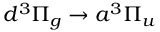<formula> <loc_0><loc_0><loc_500><loc_500>d ^ { 3 } \Pi _ { g } \rightarrow a ^ { 3 } \Pi _ { u }</formula> 